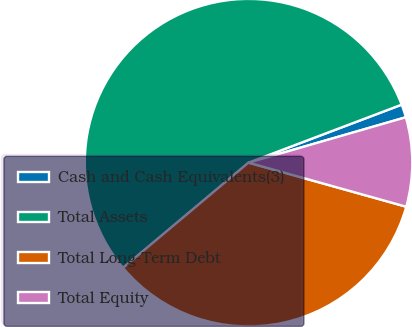Convert chart to OTSL. <chart><loc_0><loc_0><loc_500><loc_500><pie_chart><fcel>Cash and Cash Equivalents(3)<fcel>Total Assets<fcel>Total Long-Term Debt<fcel>Total Equity<nl><fcel>1.29%<fcel>55.34%<fcel>34.56%<fcel>8.81%<nl></chart> 